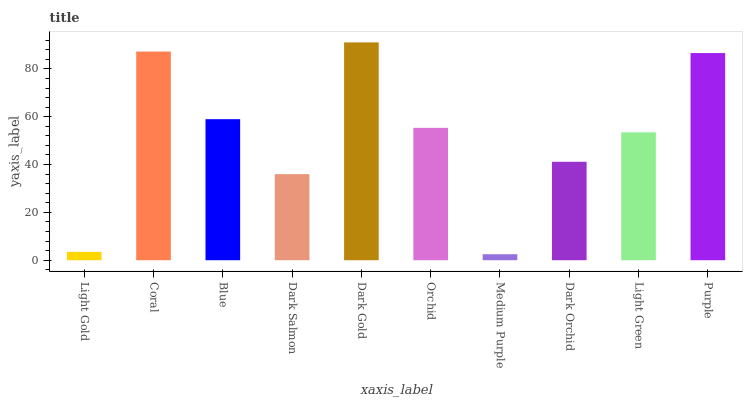Is Medium Purple the minimum?
Answer yes or no. Yes. Is Dark Gold the maximum?
Answer yes or no. Yes. Is Coral the minimum?
Answer yes or no. No. Is Coral the maximum?
Answer yes or no. No. Is Coral greater than Light Gold?
Answer yes or no. Yes. Is Light Gold less than Coral?
Answer yes or no. Yes. Is Light Gold greater than Coral?
Answer yes or no. No. Is Coral less than Light Gold?
Answer yes or no. No. Is Orchid the high median?
Answer yes or no. Yes. Is Light Green the low median?
Answer yes or no. Yes. Is Dark Orchid the high median?
Answer yes or no. No. Is Medium Purple the low median?
Answer yes or no. No. 